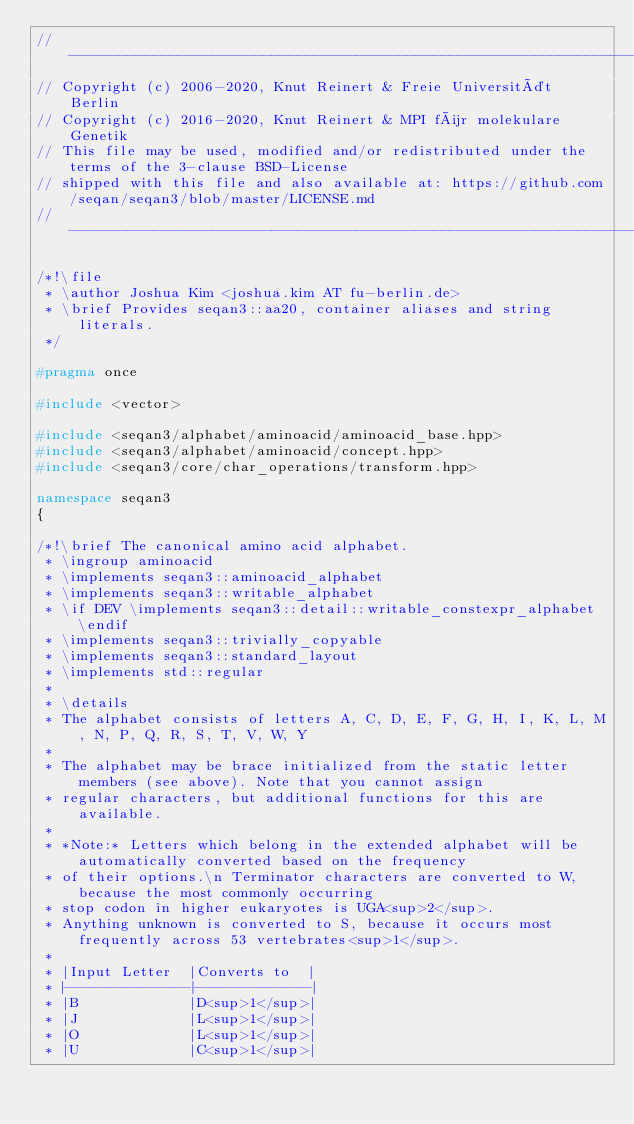<code> <loc_0><loc_0><loc_500><loc_500><_C++_>// -----------------------------------------------------------------------------------------------------
// Copyright (c) 2006-2020, Knut Reinert & Freie Universität Berlin
// Copyright (c) 2016-2020, Knut Reinert & MPI für molekulare Genetik
// This file may be used, modified and/or redistributed under the terms of the 3-clause BSD-License
// shipped with this file and also available at: https://github.com/seqan/seqan3/blob/master/LICENSE.md
// -----------------------------------------------------------------------------------------------------

/*!\file
 * \author Joshua Kim <joshua.kim AT fu-berlin.de>
 * \brief Provides seqan3::aa20, container aliases and string literals.
 */

#pragma once

#include <vector>

#include <seqan3/alphabet/aminoacid/aminoacid_base.hpp>
#include <seqan3/alphabet/aminoacid/concept.hpp>
#include <seqan3/core/char_operations/transform.hpp>

namespace seqan3
{

/*!\brief The canonical amino acid alphabet.
 * \ingroup aminoacid
 * \implements seqan3::aminoacid_alphabet
 * \implements seqan3::writable_alphabet
 * \if DEV \implements seqan3::detail::writable_constexpr_alphabet \endif
 * \implements seqan3::trivially_copyable
 * \implements seqan3::standard_layout
 * \implements std::regular
 *
 * \details
 * The alphabet consists of letters A, C, D, E, F, G, H, I, K, L, M, N, P, Q, R, S, T, V, W, Y
 *
 * The alphabet may be brace initialized from the static letter members (see above). Note that you cannot assign
 * regular characters, but additional functions for this are available.
 *
 * *Note:* Letters which belong in the extended alphabet will be automatically converted based on the frequency
 * of their options.\n Terminator characters are converted to W, because the most commonly occurring
 * stop codon in higher eukaryotes is UGA<sup>2</sup>.
 * Anything unknown is converted to S, because it occurs most frequently across 53 vertebrates<sup>1</sup>.
 *
 * |Input Letter  |Converts to  |
 * |--------------|-------------|
 * |B             |D<sup>1</sup>|
 * |J             |L<sup>1</sup>|
 * |O             |L<sup>1</sup>|
 * |U             |C<sup>1</sup>|</code> 